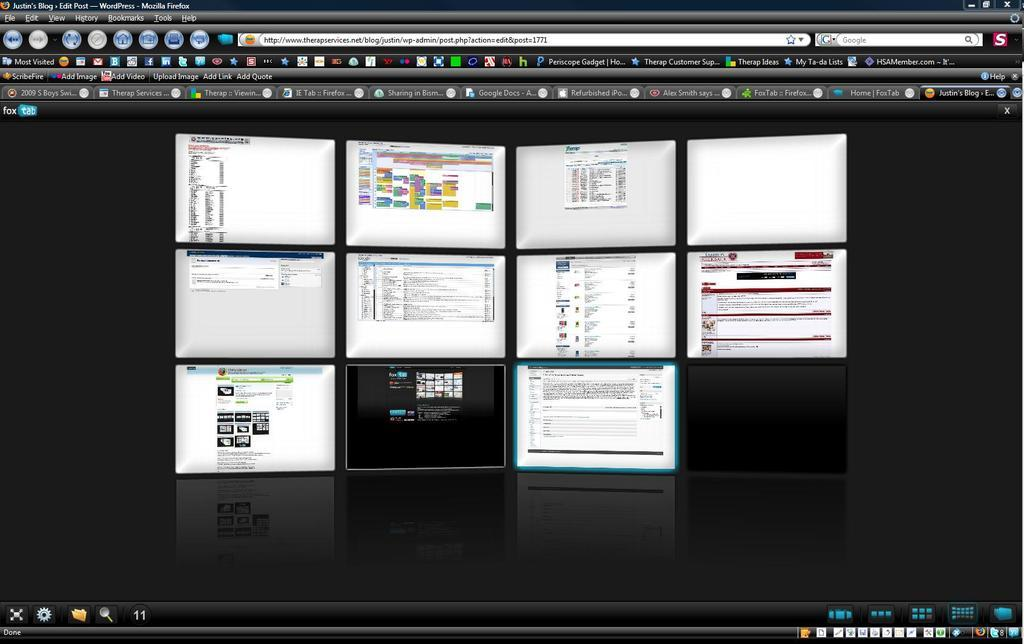What is the main object in the image? There is a monitor display in the image. How many tabs are visible on the monitor display? The monitor display has many tabs. What can be adjusted or selected on the monitor display? The monitor display has various options. What type of lunch is being served in the image? There is no lunch present in the image; it only features a monitor display. Can you tell me how much pain the person in the image is experiencing? There is no person present in the image, so it is impossible to determine their level of pain. 